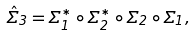Convert formula to latex. <formula><loc_0><loc_0><loc_500><loc_500>\hat { \Sigma } _ { 3 } = \Sigma _ { 1 } ^ { * } \circ \Sigma _ { 2 } ^ { * } \circ \Sigma _ { 2 } \circ \Sigma _ { 1 } ,</formula> 